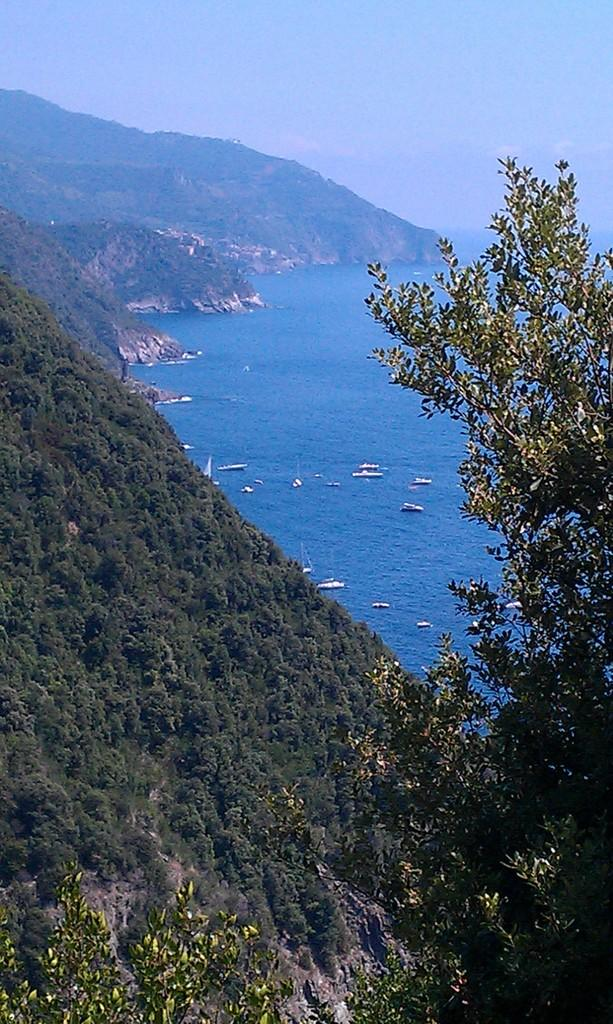What type of vegetation can be seen in the image? There are trees in the image. What is on the water in the image? There are boats on the water in the image. What type of landscape feature is visible in the image? There are hills visible in the image. What part of the natural environment is visible in the image? The sky is visible in the image. Is there any quicksand visible in the image? No, there is no quicksand present in the image. What type of branch can be seen on the trees in the image? There is no specific branch mentioned or visible in the image; only trees are mentioned. 